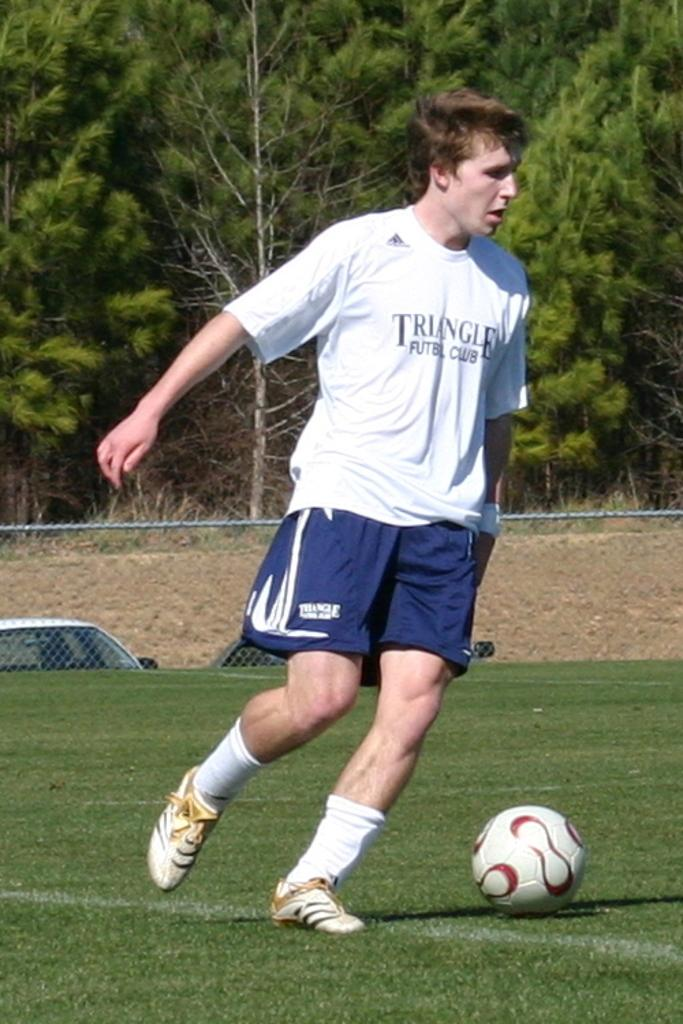<image>
Write a terse but informative summary of the picture. A man in a Triangle Futbol Club shirt dribbles the soccer ball. 